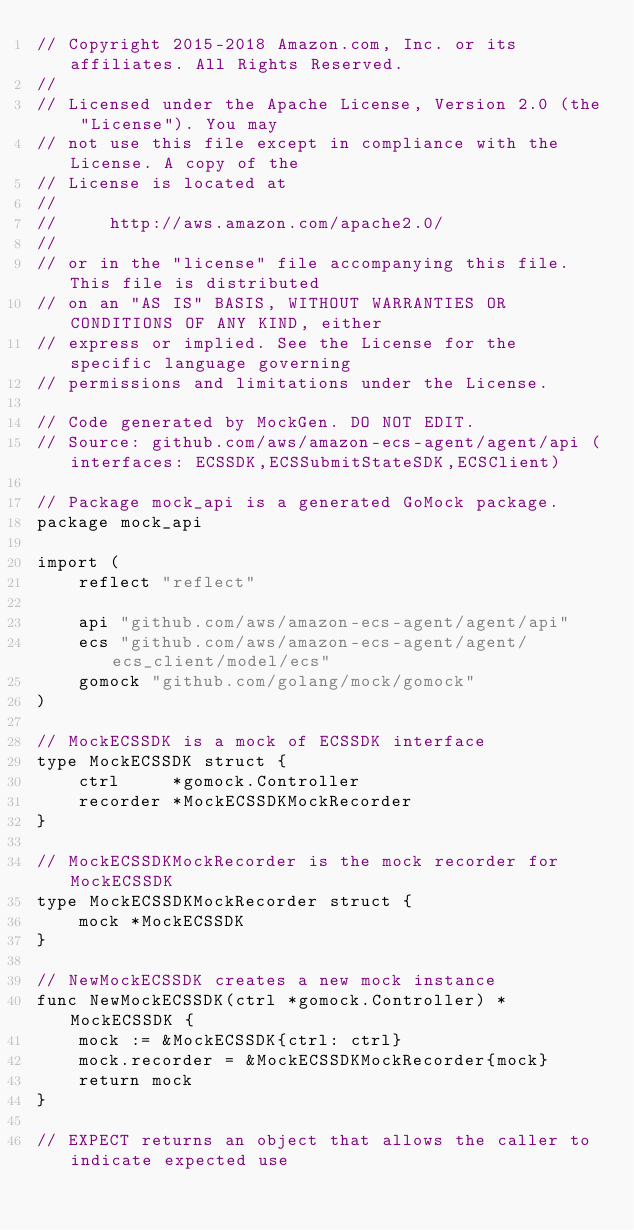Convert code to text. <code><loc_0><loc_0><loc_500><loc_500><_Go_>// Copyright 2015-2018 Amazon.com, Inc. or its affiliates. All Rights Reserved.
//
// Licensed under the Apache License, Version 2.0 (the "License"). You may
// not use this file except in compliance with the License. A copy of the
// License is located at
//
//     http://aws.amazon.com/apache2.0/
//
// or in the "license" file accompanying this file. This file is distributed
// on an "AS IS" BASIS, WITHOUT WARRANTIES OR CONDITIONS OF ANY KIND, either
// express or implied. See the License for the specific language governing
// permissions and limitations under the License.

// Code generated by MockGen. DO NOT EDIT.
// Source: github.com/aws/amazon-ecs-agent/agent/api (interfaces: ECSSDK,ECSSubmitStateSDK,ECSClient)

// Package mock_api is a generated GoMock package.
package mock_api

import (
	reflect "reflect"

	api "github.com/aws/amazon-ecs-agent/agent/api"
	ecs "github.com/aws/amazon-ecs-agent/agent/ecs_client/model/ecs"
	gomock "github.com/golang/mock/gomock"
)

// MockECSSDK is a mock of ECSSDK interface
type MockECSSDK struct {
	ctrl     *gomock.Controller
	recorder *MockECSSDKMockRecorder
}

// MockECSSDKMockRecorder is the mock recorder for MockECSSDK
type MockECSSDKMockRecorder struct {
	mock *MockECSSDK
}

// NewMockECSSDK creates a new mock instance
func NewMockECSSDK(ctrl *gomock.Controller) *MockECSSDK {
	mock := &MockECSSDK{ctrl: ctrl}
	mock.recorder = &MockECSSDKMockRecorder{mock}
	return mock
}

// EXPECT returns an object that allows the caller to indicate expected use</code> 